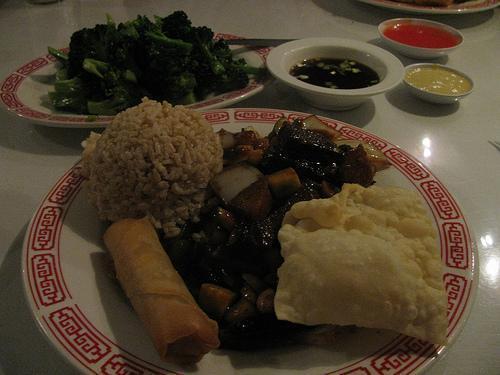How many egg rolls are there?
Give a very brief answer. 2. 